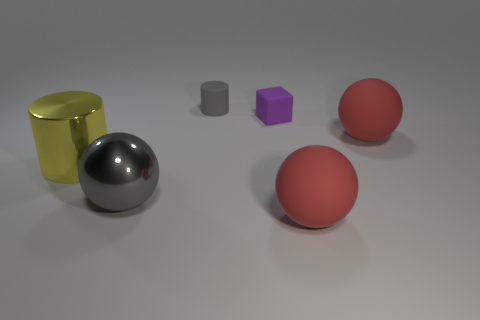Subtract all red balls. How many balls are left? 1 Add 1 tiny green blocks. How many objects exist? 7 Subtract all cylinders. How many objects are left? 4 Subtract all green blocks. How many red spheres are left? 2 Subtract all gray cylinders. How many cylinders are left? 1 Add 2 big rubber balls. How many big rubber balls exist? 4 Subtract 0 blue blocks. How many objects are left? 6 Subtract 1 cylinders. How many cylinders are left? 1 Subtract all cyan blocks. Subtract all cyan balls. How many blocks are left? 1 Subtract all purple cubes. Subtract all gray metallic objects. How many objects are left? 4 